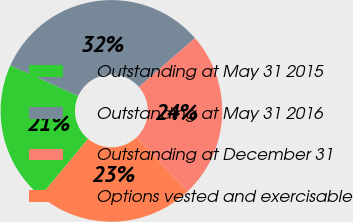Convert chart. <chart><loc_0><loc_0><loc_500><loc_500><pie_chart><fcel>Outstanding at May 31 2015<fcel>Outstanding at May 31 2016<fcel>Outstanding at December 31<fcel>Options vested and exercisable<nl><fcel>20.69%<fcel>31.86%<fcel>24.33%<fcel>23.12%<nl></chart> 